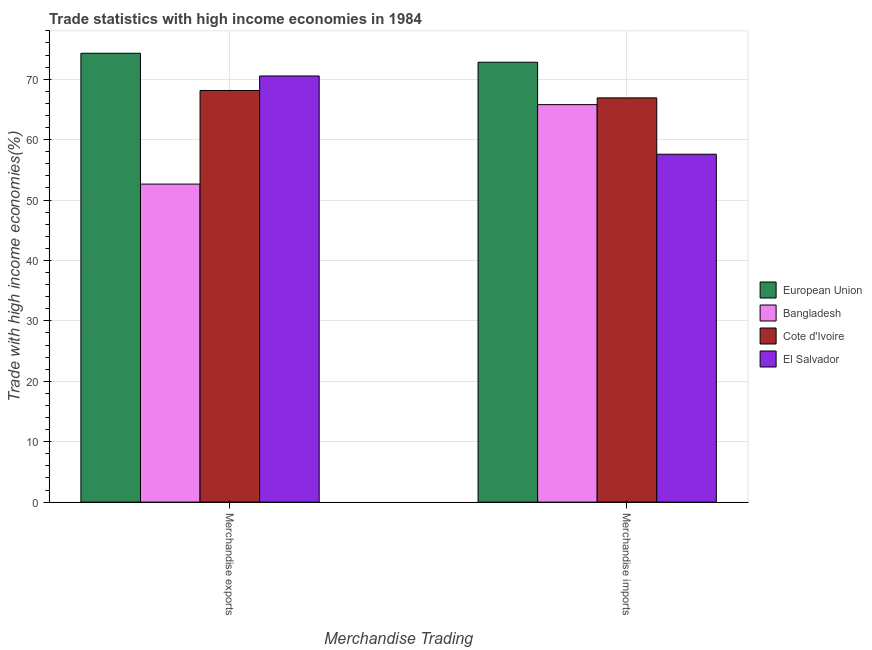Are the number of bars on each tick of the X-axis equal?
Your response must be concise. Yes. What is the merchandise imports in European Union?
Your answer should be compact. 72.81. Across all countries, what is the maximum merchandise exports?
Your answer should be compact. 74.29. Across all countries, what is the minimum merchandise exports?
Offer a terse response. 52.64. In which country was the merchandise imports minimum?
Keep it short and to the point. El Salvador. What is the total merchandise exports in the graph?
Make the answer very short. 265.6. What is the difference between the merchandise exports in Bangladesh and that in Cote d'Ivoire?
Your response must be concise. -15.49. What is the difference between the merchandise exports in Cote d'Ivoire and the merchandise imports in European Union?
Offer a very short reply. -4.68. What is the average merchandise imports per country?
Offer a very short reply. 65.77. What is the difference between the merchandise exports and merchandise imports in El Salvador?
Ensure brevity in your answer.  12.95. What is the ratio of the merchandise exports in Cote d'Ivoire to that in European Union?
Your answer should be compact. 0.92. Is the merchandise exports in El Salvador less than that in Cote d'Ivoire?
Make the answer very short. No. In how many countries, is the merchandise exports greater than the average merchandise exports taken over all countries?
Provide a succinct answer. 3. What does the 1st bar from the left in Merchandise imports represents?
Provide a succinct answer. European Union. What does the 3rd bar from the right in Merchandise imports represents?
Your answer should be compact. Bangladesh. How many countries are there in the graph?
Make the answer very short. 4. What is the difference between two consecutive major ticks on the Y-axis?
Your answer should be compact. 10. Are the values on the major ticks of Y-axis written in scientific E-notation?
Keep it short and to the point. No. Does the graph contain any zero values?
Keep it short and to the point. No. How many legend labels are there?
Your response must be concise. 4. What is the title of the graph?
Offer a very short reply. Trade statistics with high income economies in 1984. Does "Faeroe Islands" appear as one of the legend labels in the graph?
Offer a very short reply. No. What is the label or title of the X-axis?
Give a very brief answer. Merchandise Trading. What is the label or title of the Y-axis?
Offer a terse response. Trade with high income economies(%). What is the Trade with high income economies(%) of European Union in Merchandise exports?
Provide a short and direct response. 74.29. What is the Trade with high income economies(%) in Bangladesh in Merchandise exports?
Offer a very short reply. 52.64. What is the Trade with high income economies(%) in Cote d'Ivoire in Merchandise exports?
Keep it short and to the point. 68.13. What is the Trade with high income economies(%) of El Salvador in Merchandise exports?
Give a very brief answer. 70.53. What is the Trade with high income economies(%) of European Union in Merchandise imports?
Make the answer very short. 72.81. What is the Trade with high income economies(%) in Bangladesh in Merchandise imports?
Provide a short and direct response. 65.79. What is the Trade with high income economies(%) in Cote d'Ivoire in Merchandise imports?
Offer a very short reply. 66.91. What is the Trade with high income economies(%) in El Salvador in Merchandise imports?
Offer a terse response. 57.58. Across all Merchandise Trading, what is the maximum Trade with high income economies(%) in European Union?
Give a very brief answer. 74.29. Across all Merchandise Trading, what is the maximum Trade with high income economies(%) in Bangladesh?
Your answer should be compact. 65.79. Across all Merchandise Trading, what is the maximum Trade with high income economies(%) of Cote d'Ivoire?
Your answer should be very brief. 68.13. Across all Merchandise Trading, what is the maximum Trade with high income economies(%) in El Salvador?
Provide a succinct answer. 70.53. Across all Merchandise Trading, what is the minimum Trade with high income economies(%) of European Union?
Your answer should be compact. 72.81. Across all Merchandise Trading, what is the minimum Trade with high income economies(%) in Bangladesh?
Give a very brief answer. 52.64. Across all Merchandise Trading, what is the minimum Trade with high income economies(%) of Cote d'Ivoire?
Offer a terse response. 66.91. Across all Merchandise Trading, what is the minimum Trade with high income economies(%) in El Salvador?
Provide a succinct answer. 57.58. What is the total Trade with high income economies(%) in European Union in the graph?
Your response must be concise. 147.1. What is the total Trade with high income economies(%) in Bangladesh in the graph?
Ensure brevity in your answer.  118.43. What is the total Trade with high income economies(%) in Cote d'Ivoire in the graph?
Offer a terse response. 135.04. What is the total Trade with high income economies(%) in El Salvador in the graph?
Give a very brief answer. 128.11. What is the difference between the Trade with high income economies(%) of European Union in Merchandise exports and that in Merchandise imports?
Offer a very short reply. 1.48. What is the difference between the Trade with high income economies(%) in Bangladesh in Merchandise exports and that in Merchandise imports?
Give a very brief answer. -13.15. What is the difference between the Trade with high income economies(%) of Cote d'Ivoire in Merchandise exports and that in Merchandise imports?
Give a very brief answer. 1.23. What is the difference between the Trade with high income economies(%) of El Salvador in Merchandise exports and that in Merchandise imports?
Offer a very short reply. 12.95. What is the difference between the Trade with high income economies(%) in European Union in Merchandise exports and the Trade with high income economies(%) in Bangladesh in Merchandise imports?
Ensure brevity in your answer.  8.5. What is the difference between the Trade with high income economies(%) of European Union in Merchandise exports and the Trade with high income economies(%) of Cote d'Ivoire in Merchandise imports?
Ensure brevity in your answer.  7.38. What is the difference between the Trade with high income economies(%) of European Union in Merchandise exports and the Trade with high income economies(%) of El Salvador in Merchandise imports?
Provide a succinct answer. 16.71. What is the difference between the Trade with high income economies(%) in Bangladesh in Merchandise exports and the Trade with high income economies(%) in Cote d'Ivoire in Merchandise imports?
Offer a very short reply. -14.27. What is the difference between the Trade with high income economies(%) of Bangladesh in Merchandise exports and the Trade with high income economies(%) of El Salvador in Merchandise imports?
Your answer should be compact. -4.94. What is the difference between the Trade with high income economies(%) in Cote d'Ivoire in Merchandise exports and the Trade with high income economies(%) in El Salvador in Merchandise imports?
Offer a terse response. 10.55. What is the average Trade with high income economies(%) in European Union per Merchandise Trading?
Keep it short and to the point. 73.55. What is the average Trade with high income economies(%) in Bangladesh per Merchandise Trading?
Your response must be concise. 59.21. What is the average Trade with high income economies(%) in Cote d'Ivoire per Merchandise Trading?
Provide a short and direct response. 67.52. What is the average Trade with high income economies(%) of El Salvador per Merchandise Trading?
Give a very brief answer. 64.06. What is the difference between the Trade with high income economies(%) in European Union and Trade with high income economies(%) in Bangladesh in Merchandise exports?
Provide a succinct answer. 21.65. What is the difference between the Trade with high income economies(%) of European Union and Trade with high income economies(%) of Cote d'Ivoire in Merchandise exports?
Provide a succinct answer. 6.16. What is the difference between the Trade with high income economies(%) in European Union and Trade with high income economies(%) in El Salvador in Merchandise exports?
Your answer should be very brief. 3.76. What is the difference between the Trade with high income economies(%) in Bangladesh and Trade with high income economies(%) in Cote d'Ivoire in Merchandise exports?
Ensure brevity in your answer.  -15.49. What is the difference between the Trade with high income economies(%) in Bangladesh and Trade with high income economies(%) in El Salvador in Merchandise exports?
Give a very brief answer. -17.89. What is the difference between the Trade with high income economies(%) of Cote d'Ivoire and Trade with high income economies(%) of El Salvador in Merchandise exports?
Offer a very short reply. -2.4. What is the difference between the Trade with high income economies(%) in European Union and Trade with high income economies(%) in Bangladesh in Merchandise imports?
Offer a very short reply. 7.02. What is the difference between the Trade with high income economies(%) in European Union and Trade with high income economies(%) in Cote d'Ivoire in Merchandise imports?
Make the answer very short. 5.9. What is the difference between the Trade with high income economies(%) of European Union and Trade with high income economies(%) of El Salvador in Merchandise imports?
Your response must be concise. 15.23. What is the difference between the Trade with high income economies(%) in Bangladesh and Trade with high income economies(%) in Cote d'Ivoire in Merchandise imports?
Provide a succinct answer. -1.12. What is the difference between the Trade with high income economies(%) of Bangladesh and Trade with high income economies(%) of El Salvador in Merchandise imports?
Make the answer very short. 8.21. What is the difference between the Trade with high income economies(%) in Cote d'Ivoire and Trade with high income economies(%) in El Salvador in Merchandise imports?
Provide a short and direct response. 9.33. What is the ratio of the Trade with high income economies(%) of European Union in Merchandise exports to that in Merchandise imports?
Give a very brief answer. 1.02. What is the ratio of the Trade with high income economies(%) of Bangladesh in Merchandise exports to that in Merchandise imports?
Give a very brief answer. 0.8. What is the ratio of the Trade with high income economies(%) of Cote d'Ivoire in Merchandise exports to that in Merchandise imports?
Your answer should be compact. 1.02. What is the ratio of the Trade with high income economies(%) in El Salvador in Merchandise exports to that in Merchandise imports?
Give a very brief answer. 1.22. What is the difference between the highest and the second highest Trade with high income economies(%) of European Union?
Give a very brief answer. 1.48. What is the difference between the highest and the second highest Trade with high income economies(%) of Bangladesh?
Make the answer very short. 13.15. What is the difference between the highest and the second highest Trade with high income economies(%) of Cote d'Ivoire?
Offer a terse response. 1.23. What is the difference between the highest and the second highest Trade with high income economies(%) of El Salvador?
Offer a terse response. 12.95. What is the difference between the highest and the lowest Trade with high income economies(%) of European Union?
Offer a very short reply. 1.48. What is the difference between the highest and the lowest Trade with high income economies(%) of Bangladesh?
Provide a succinct answer. 13.15. What is the difference between the highest and the lowest Trade with high income economies(%) of Cote d'Ivoire?
Make the answer very short. 1.23. What is the difference between the highest and the lowest Trade with high income economies(%) in El Salvador?
Give a very brief answer. 12.95. 